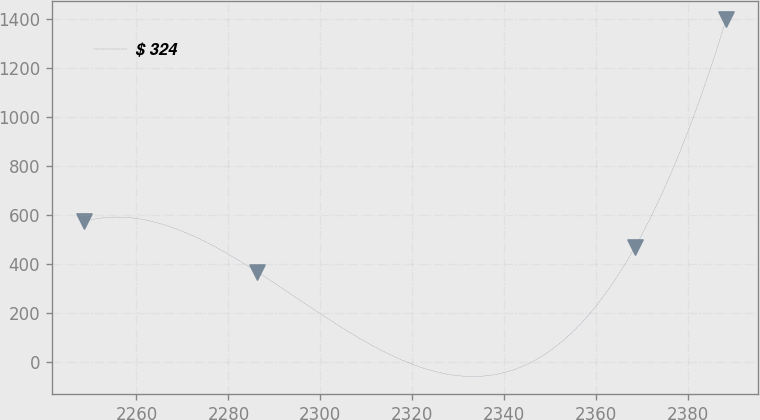Convert chart to OTSL. <chart><loc_0><loc_0><loc_500><loc_500><line_chart><ecel><fcel>$ 324<nl><fcel>2248.61<fcel>574.49<nl><fcel>2286.31<fcel>368.11<nl><fcel>2368.45<fcel>471.3<nl><fcel>2388.24<fcel>1399.98<nl></chart> 